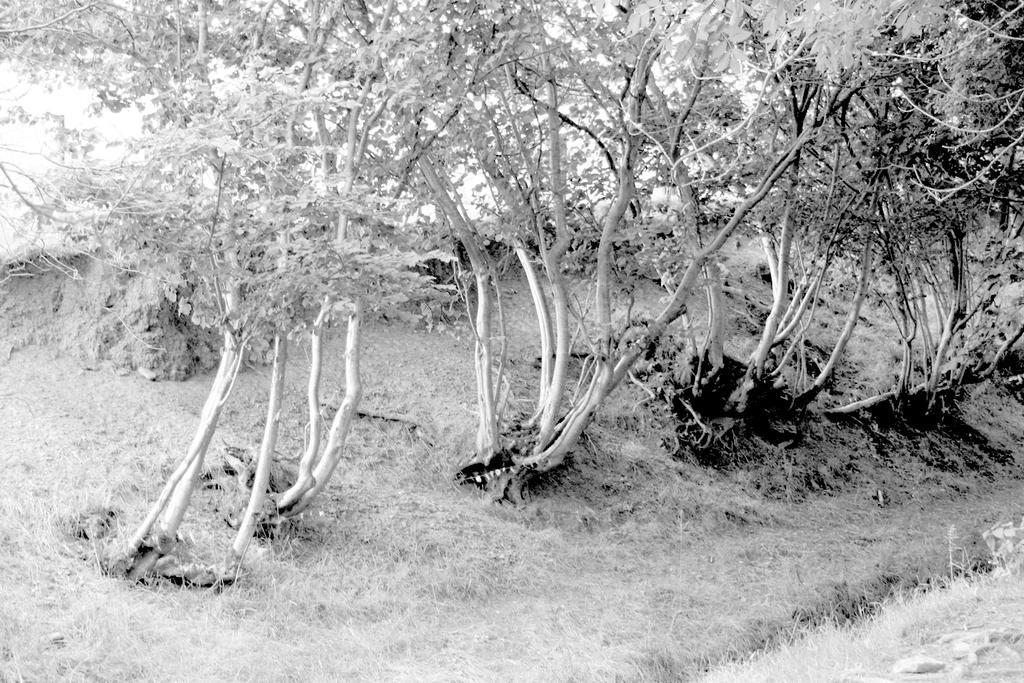Can you describe this image briefly? In this picture I can see grass, plants and trees. 